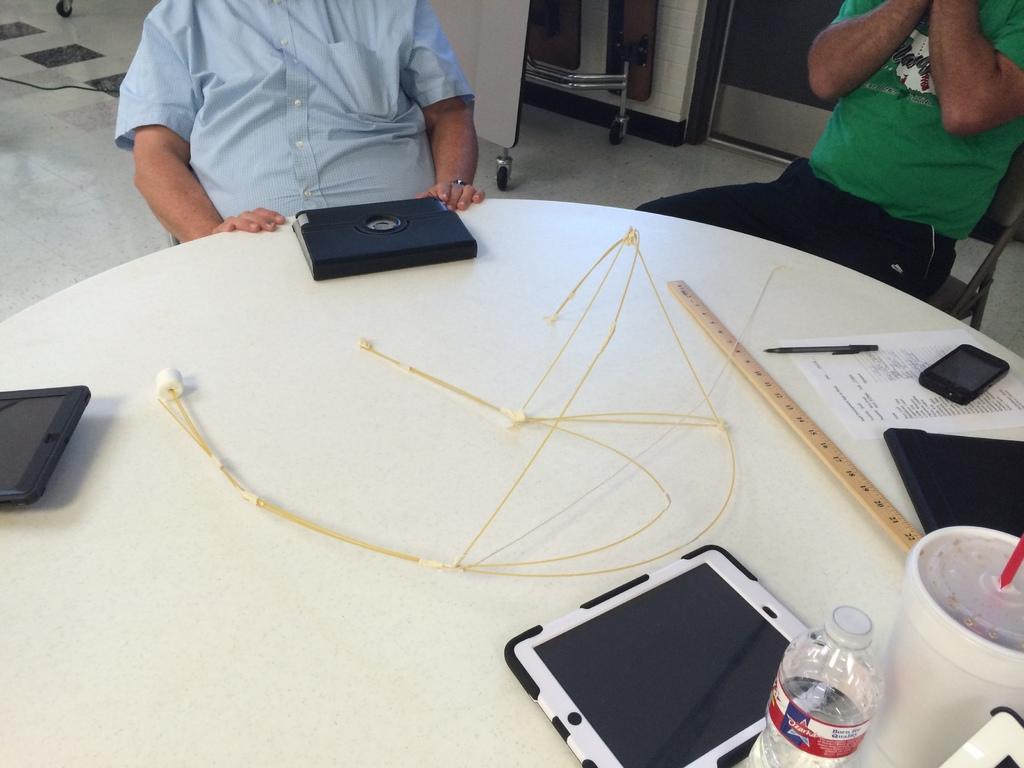Please provide a concise description of this image. There are two persons sitting in front of a table and the table consists of i pads,water bottle,coke,scale,paper,phone and pen. 